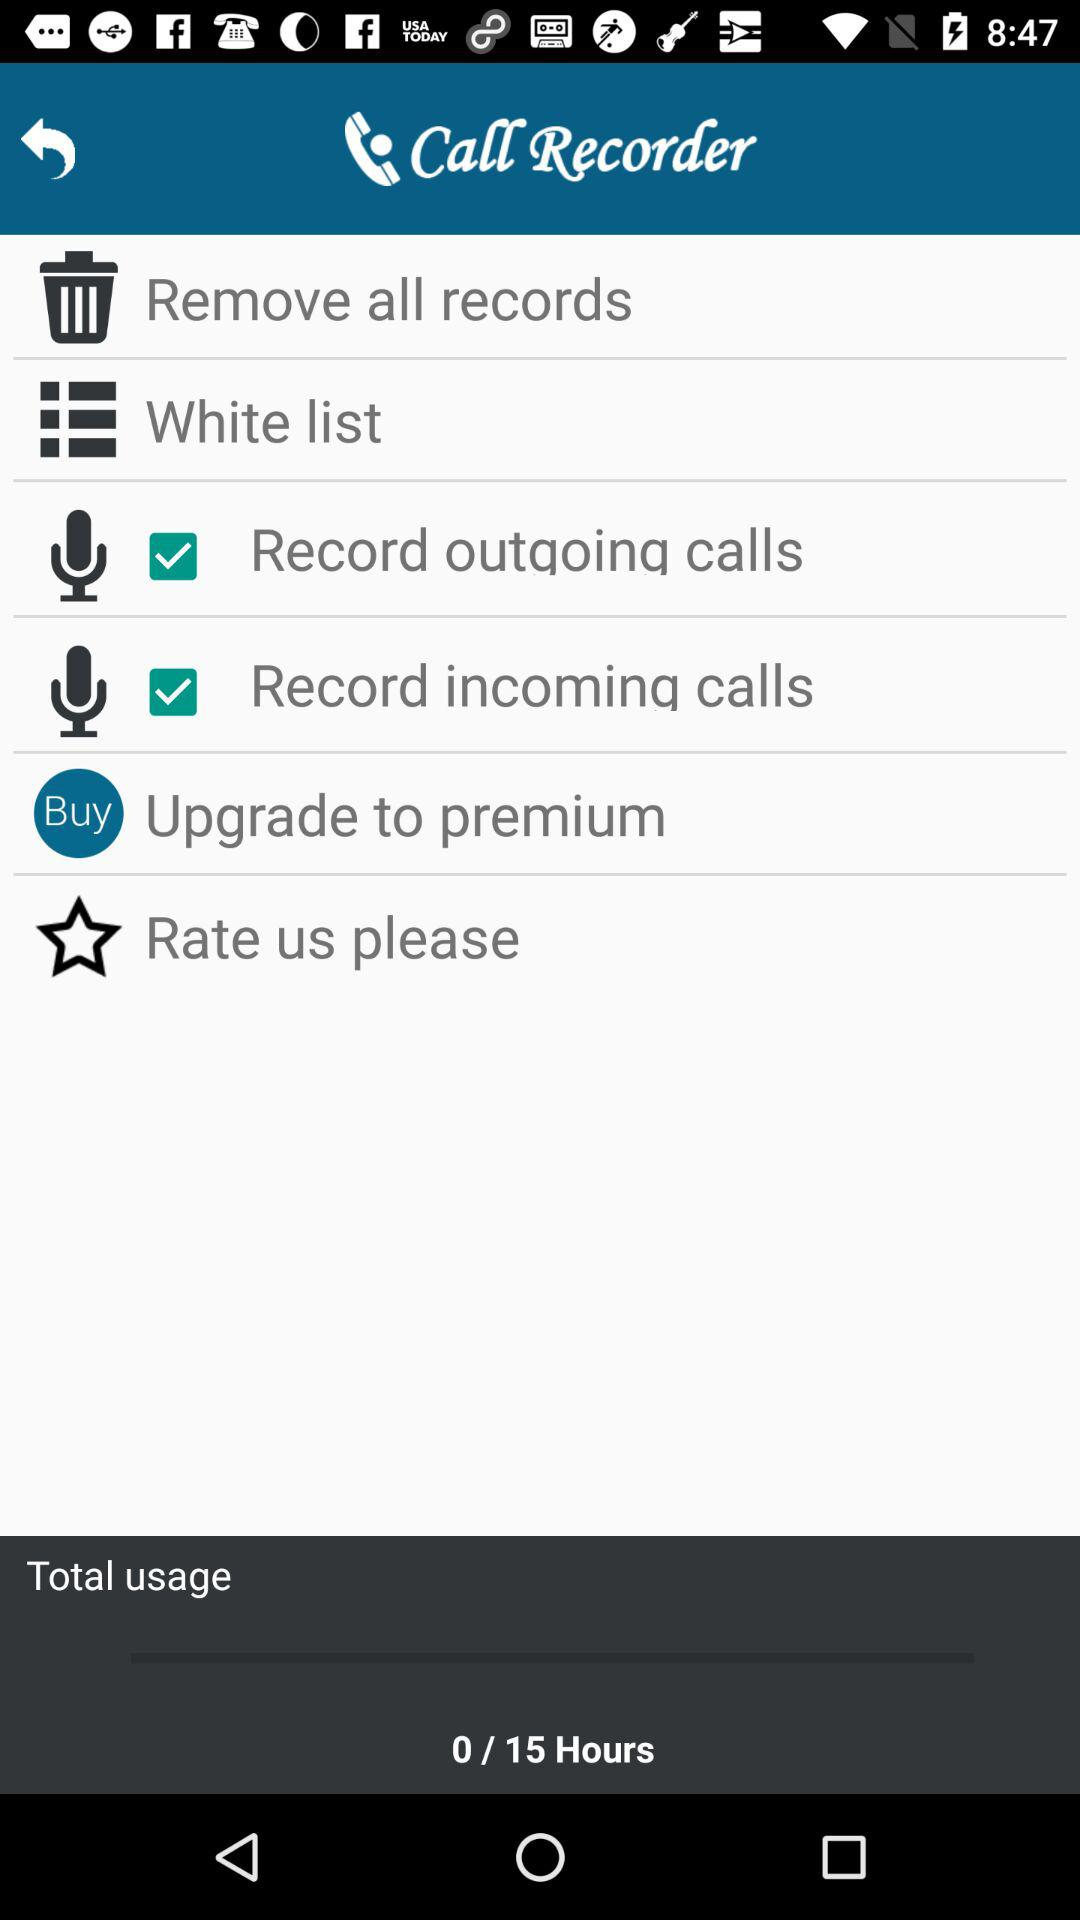What is the status of "Record outgoing calls"? The status of "Record outgoing calls" is "on". 